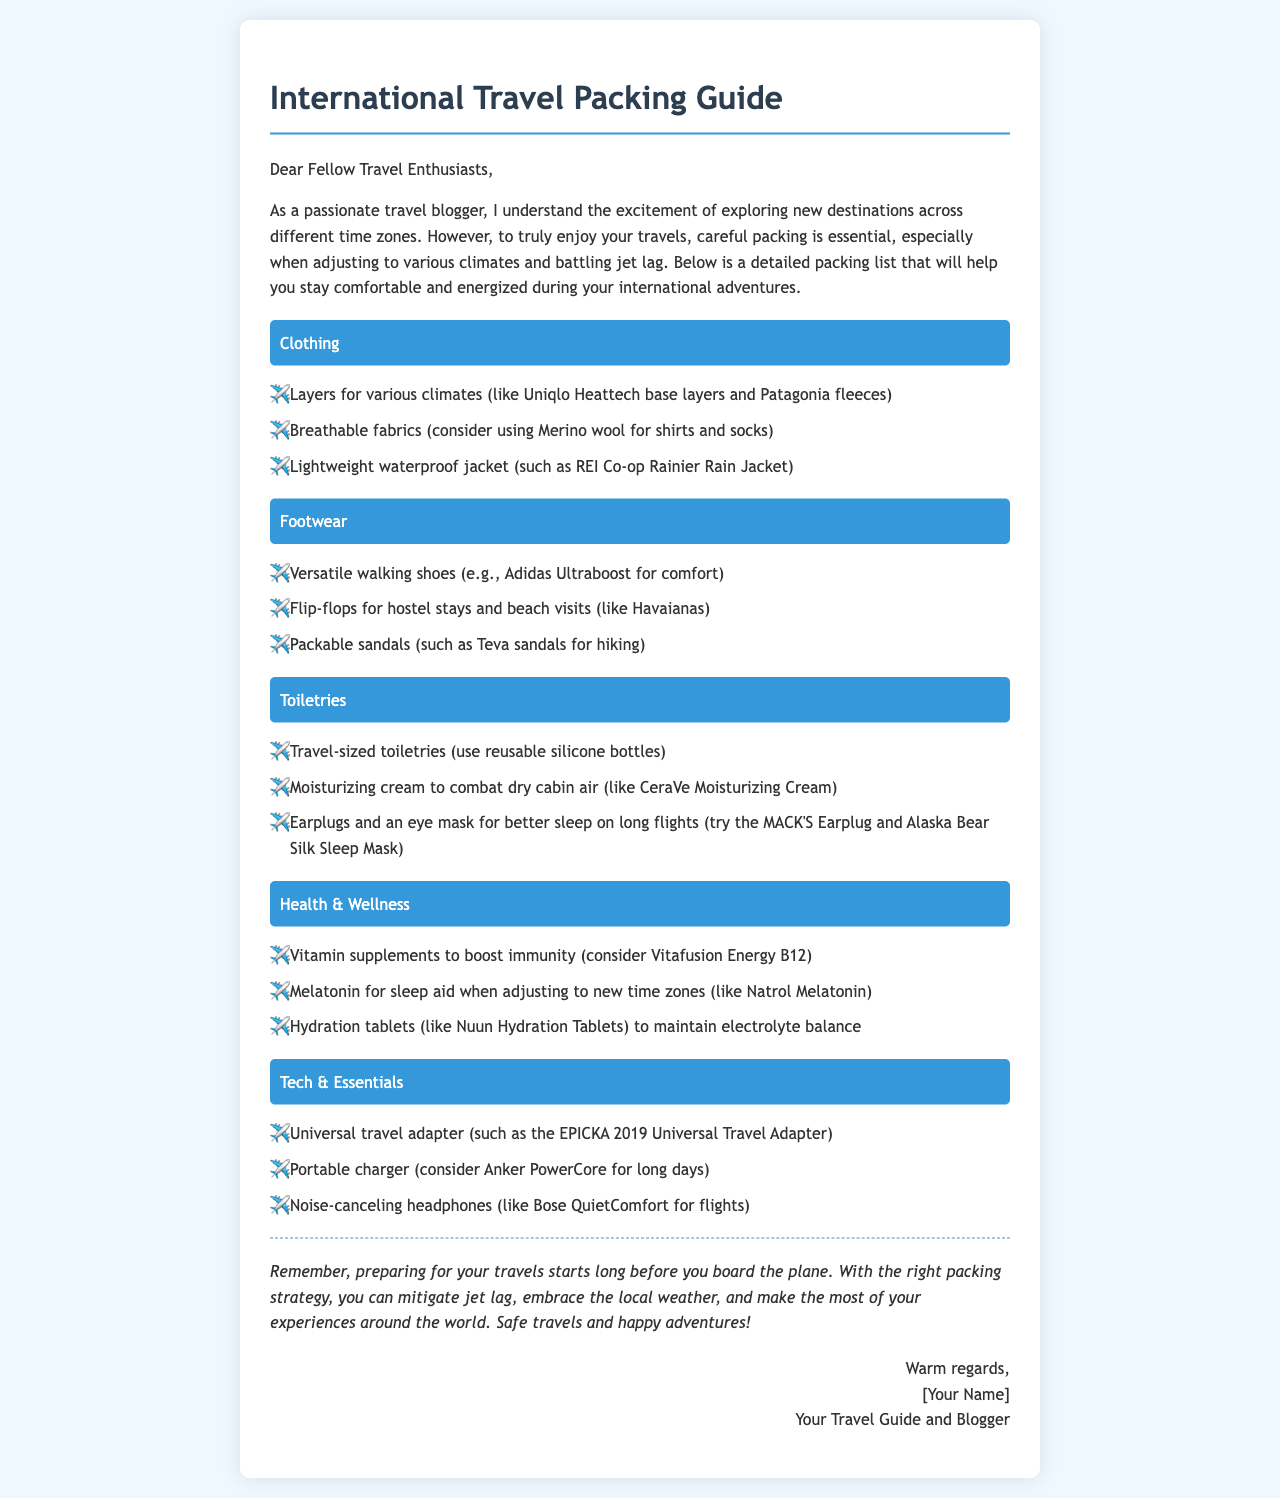What are the recommended layers for various climates? The letter suggests using Uniqlo Heattech base layers and Patagonia fleeces as layers for various climates.
Answer: Uniqlo Heattech base layers and Patagonia fleeces What type of footwear is suggested for hiking? According to the letter, packable sandals such as Teva sandals are recommended for hiking.
Answer: Teva sandals Which cream is recommended to combat dry cabin air? The document mentions CeraVe Moisturizing Cream as a moisturizing cream to combat dry cabin air.
Answer: CeraVe Moisturizing Cream What vitamin supplement is suggested to boost immunity? The letter recommends Vitafusion Energy B12 as a vitamin supplement to boost immunity.
Answer: Vitafusion Energy B12 What item is advised for better sleep on long flights? The document contains a suggestion for using earplugs and an eye mask for better sleep on long flights.
Answer: Earplugs and an eye mask Why is hydration important during international travel? The need for hydration is emphasized in relation to maintaining electrolyte balance, particularly with hydration tablets mentioned in the letter.
Answer: To maintain electrolyte balance What type of adapter is recommended for international use? The letter specifies using the EPICKA 2019 Universal Travel Adapter for international travel needs.
Answer: EPICKA 2019 Universal Travel Adapter What is the overarching theme of this packing guide? The letter's main focus is on careful packing to adjust to various climates and prevent jet lag during international travels.
Answer: Adjust to various climates and prevent jet lag How does the author suggest mitigating jet lag? The author discusses the importance of melatonin as a sleep aid when adjusting to new time zones.
Answer: Melatonin 